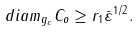Convert formula to latex. <formula><loc_0><loc_0><loc_500><loc_500>d i a m _ { g _ { \varepsilon } } C _ { o } \geq r _ { 1 } \bar { \varepsilon } ^ { 1 / 2 } .</formula> 